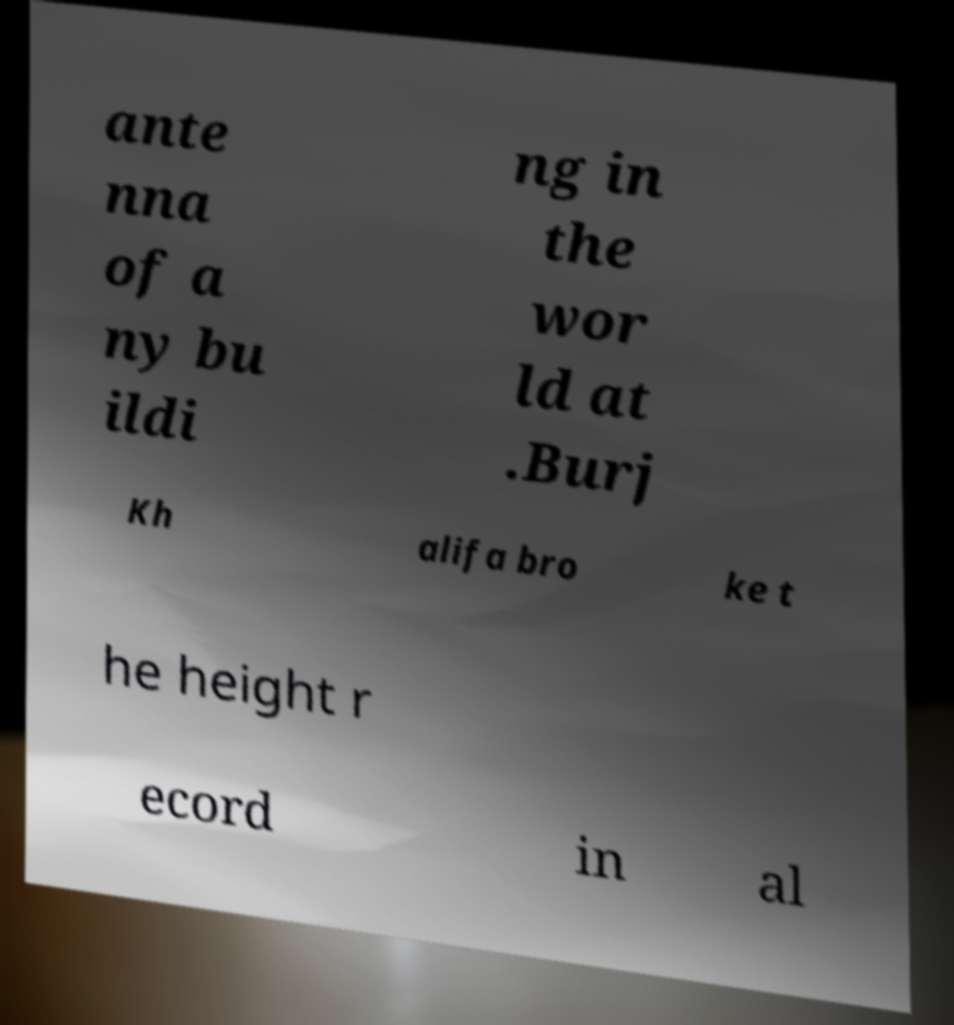Please read and relay the text visible in this image. What does it say? ante nna of a ny bu ildi ng in the wor ld at .Burj Kh alifa bro ke t he height r ecord in al 